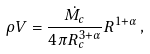<formula> <loc_0><loc_0><loc_500><loc_500>\rho V = \frac { \dot { M _ { c } } } { 4 \pi R ^ { 3 + \alpha } _ { c } } R ^ { 1 + \alpha } \, ,</formula> 